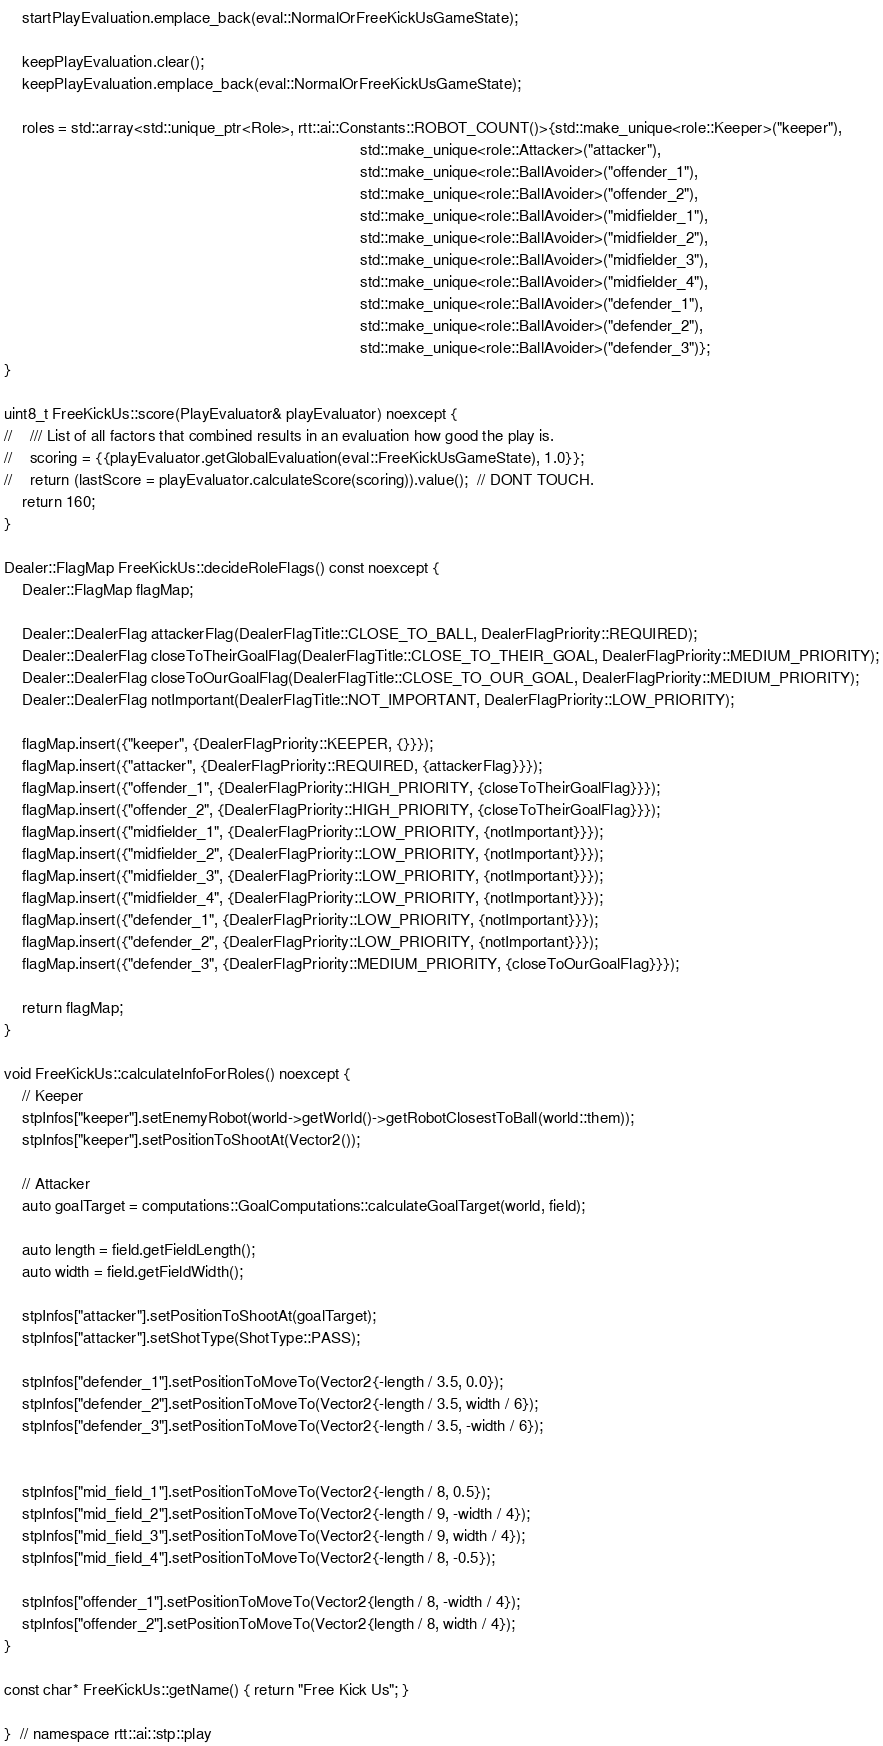Convert code to text. <code><loc_0><loc_0><loc_500><loc_500><_C++_>    startPlayEvaluation.emplace_back(eval::NormalOrFreeKickUsGameState);

    keepPlayEvaluation.clear();
    keepPlayEvaluation.emplace_back(eval::NormalOrFreeKickUsGameState);

    roles = std::array<std::unique_ptr<Role>, rtt::ai::Constants::ROBOT_COUNT()>{std::make_unique<role::Keeper>("keeper"),
                                                                                 std::make_unique<role::Attacker>("attacker"),
                                                                                 std::make_unique<role::BallAvoider>("offender_1"),
                                                                                 std::make_unique<role::BallAvoider>("offender_2"),
                                                                                 std::make_unique<role::BallAvoider>("midfielder_1"),
                                                                                 std::make_unique<role::BallAvoider>("midfielder_2"),
                                                                                 std::make_unique<role::BallAvoider>("midfielder_3"),
                                                                                 std::make_unique<role::BallAvoider>("midfielder_4"),
                                                                                 std::make_unique<role::BallAvoider>("defender_1"),
                                                                                 std::make_unique<role::BallAvoider>("defender_2"),
                                                                                 std::make_unique<role::BallAvoider>("defender_3")};
}

uint8_t FreeKickUs::score(PlayEvaluator& playEvaluator) noexcept {
//    /// List of all factors that combined results in an evaluation how good the play is.
//    scoring = {{playEvaluator.getGlobalEvaluation(eval::FreeKickUsGameState), 1.0}};
//    return (lastScore = playEvaluator.calculateScore(scoring)).value();  // DONT TOUCH.
    return 160;
}

Dealer::FlagMap FreeKickUs::decideRoleFlags() const noexcept {
    Dealer::FlagMap flagMap;

    Dealer::DealerFlag attackerFlag(DealerFlagTitle::CLOSE_TO_BALL, DealerFlagPriority::REQUIRED);
    Dealer::DealerFlag closeToTheirGoalFlag(DealerFlagTitle::CLOSE_TO_THEIR_GOAL, DealerFlagPriority::MEDIUM_PRIORITY);
    Dealer::DealerFlag closeToOurGoalFlag(DealerFlagTitle::CLOSE_TO_OUR_GOAL, DealerFlagPriority::MEDIUM_PRIORITY);
    Dealer::DealerFlag notImportant(DealerFlagTitle::NOT_IMPORTANT, DealerFlagPriority::LOW_PRIORITY);

    flagMap.insert({"keeper", {DealerFlagPriority::KEEPER, {}}});
    flagMap.insert({"attacker", {DealerFlagPriority::REQUIRED, {attackerFlag}}});
    flagMap.insert({"offender_1", {DealerFlagPriority::HIGH_PRIORITY, {closeToTheirGoalFlag}}});
    flagMap.insert({"offender_2", {DealerFlagPriority::HIGH_PRIORITY, {closeToTheirGoalFlag}}});
    flagMap.insert({"midfielder_1", {DealerFlagPriority::LOW_PRIORITY, {notImportant}}});
    flagMap.insert({"midfielder_2", {DealerFlagPriority::LOW_PRIORITY, {notImportant}}});
    flagMap.insert({"midfielder_3", {DealerFlagPriority::LOW_PRIORITY, {notImportant}}});
    flagMap.insert({"midfielder_4", {DealerFlagPriority::LOW_PRIORITY, {notImportant}}});
    flagMap.insert({"defender_1", {DealerFlagPriority::LOW_PRIORITY, {notImportant}}});
    flagMap.insert({"defender_2", {DealerFlagPriority::LOW_PRIORITY, {notImportant}}});
    flagMap.insert({"defender_3", {DealerFlagPriority::MEDIUM_PRIORITY, {closeToOurGoalFlag}}});

    return flagMap;
}

void FreeKickUs::calculateInfoForRoles() noexcept {
    // Keeper
    stpInfos["keeper"].setEnemyRobot(world->getWorld()->getRobotClosestToBall(world::them));
    stpInfos["keeper"].setPositionToShootAt(Vector2());

    // Attacker
    auto goalTarget = computations::GoalComputations::calculateGoalTarget(world, field);

    auto length = field.getFieldLength();
    auto width = field.getFieldWidth();

    stpInfos["attacker"].setPositionToShootAt(goalTarget);
    stpInfos["attacker"].setShotType(ShotType::PASS);

    stpInfos["defender_1"].setPositionToMoveTo(Vector2{-length / 3.5, 0.0});
    stpInfos["defender_2"].setPositionToMoveTo(Vector2{-length / 3.5, width / 6});
    stpInfos["defender_3"].setPositionToMoveTo(Vector2{-length / 3.5, -width / 6});


    stpInfos["mid_field_1"].setPositionToMoveTo(Vector2{-length / 8, 0.5});
    stpInfos["mid_field_2"].setPositionToMoveTo(Vector2{-length / 9, -width / 4});
    stpInfos["mid_field_3"].setPositionToMoveTo(Vector2{-length / 9, width / 4});
    stpInfos["mid_field_4"].setPositionToMoveTo(Vector2{-length / 8, -0.5});

    stpInfos["offender_1"].setPositionToMoveTo(Vector2{length / 8, -width / 4});
    stpInfos["offender_2"].setPositionToMoveTo(Vector2{length / 8, width / 4});
}

const char* FreeKickUs::getName() { return "Free Kick Us"; }

}  // namespace rtt::ai::stp::play
</code> 